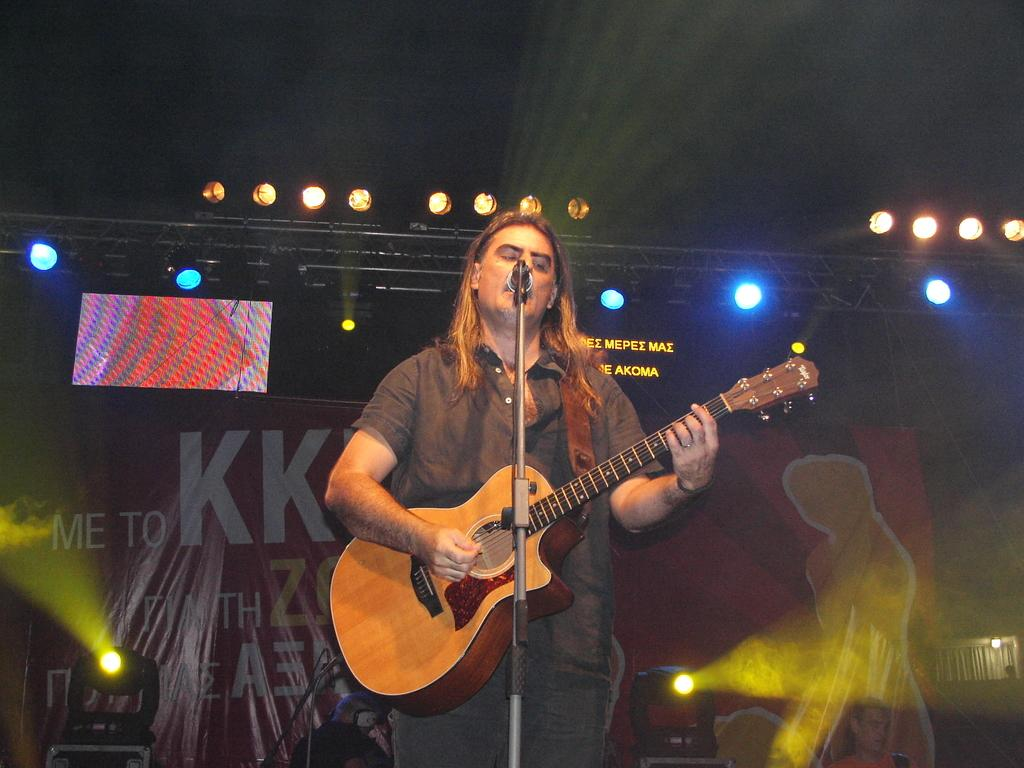What is the main subject of the image? There is a man in the image. What is the man doing in the image? The man is standing and playing the guitar with his right hand. What is the man holding in the image? The man is holding a guitar. What else is the man doing while playing the guitar? The man is singing. What type of cherry is the man using to comb his hair in the image? There is no cherry or comb present in the image. The man is playing the guitar and singing, and there is no indication of him using a cherry or comb for any purpose. 